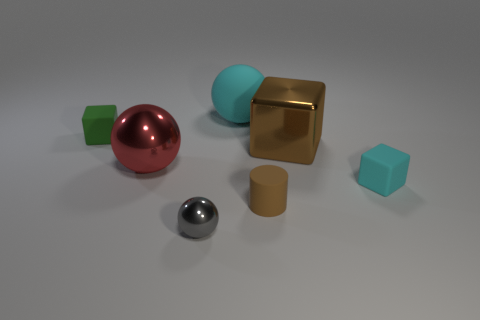Add 1 big red metallic things. How many objects exist? 8 Subtract all cylinders. How many objects are left? 6 Add 7 small brown metal cylinders. How many small brown metal cylinders exist? 7 Subtract 1 green cubes. How many objects are left? 6 Subtract all cylinders. Subtract all big red things. How many objects are left? 5 Add 2 red balls. How many red balls are left? 3 